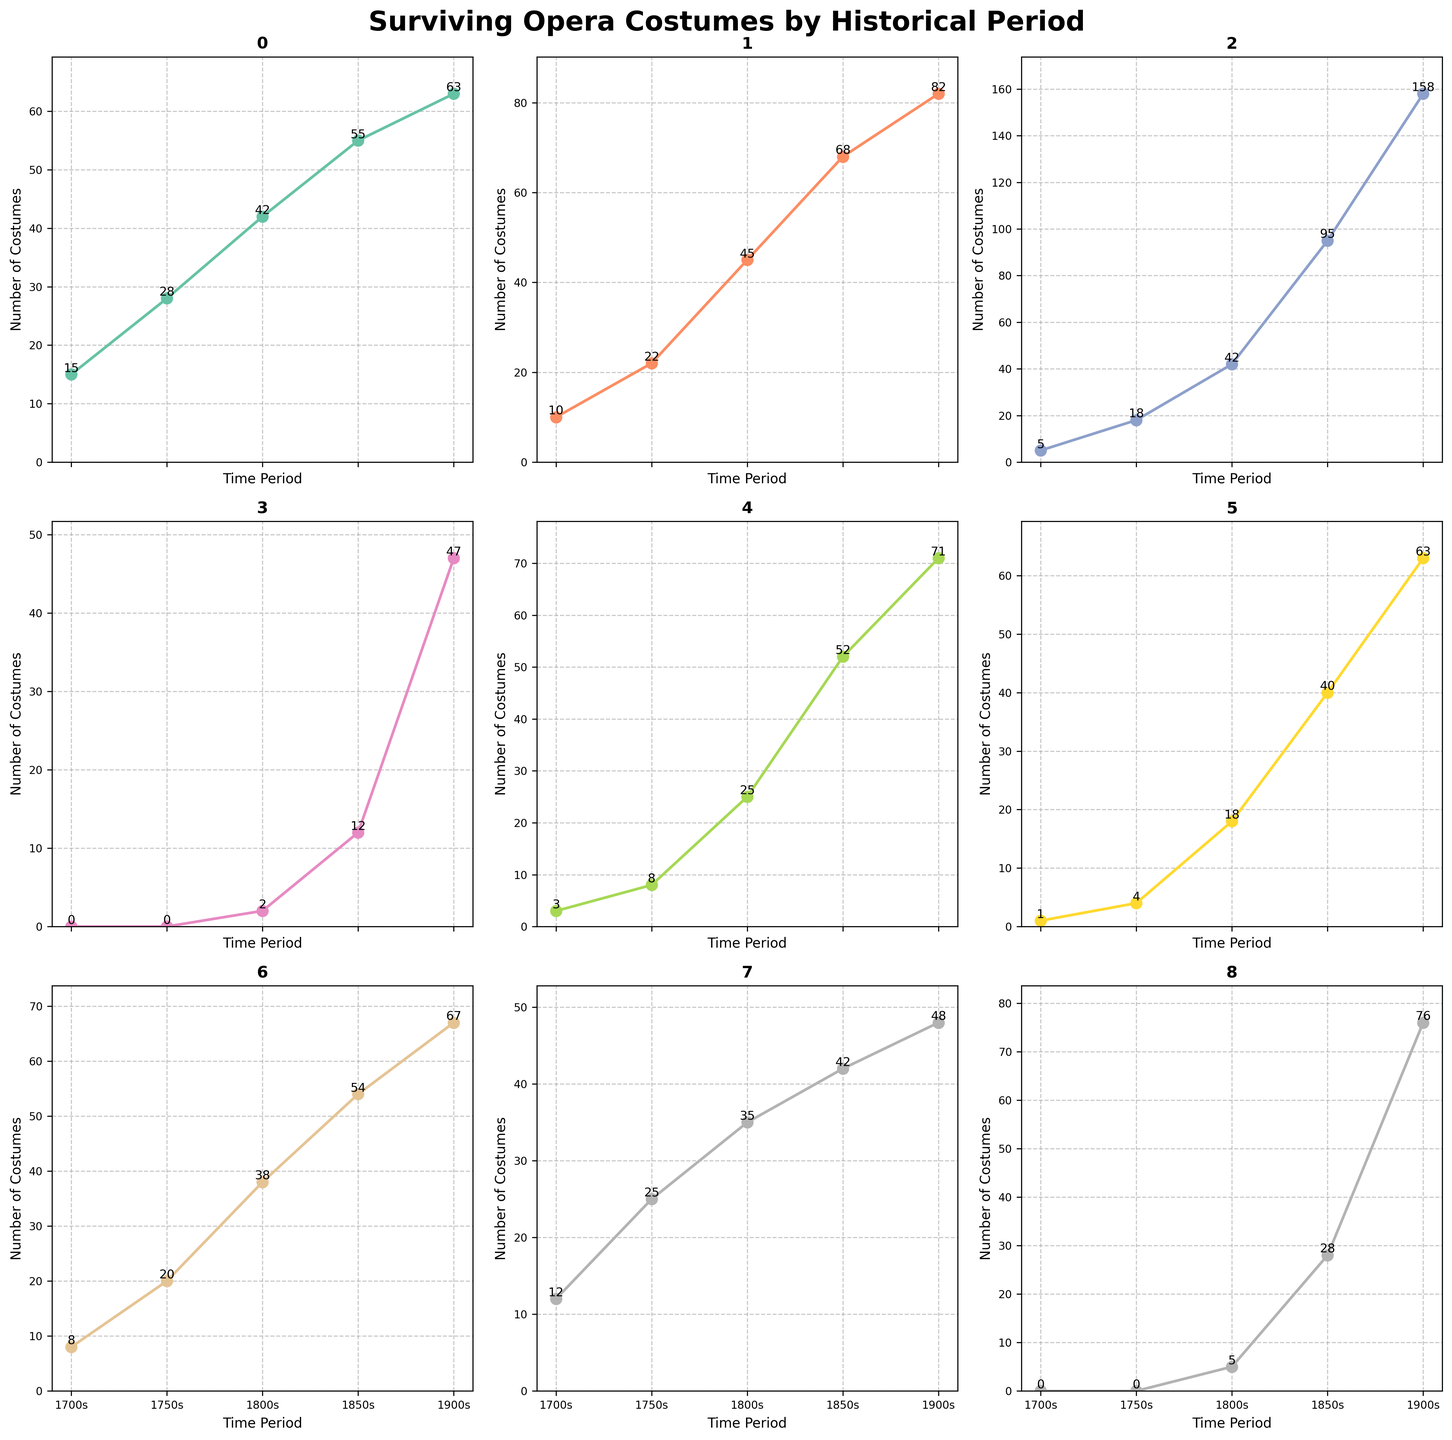How many surviving original opera costumes from the 1900s are recorded for the Romantic period? Looking at the Romantic period subplot, identify the value marked on the line for the 1900s, which is 158.
Answer: 158 Which historical period shows the highest increase in surviving costumes from the 1700s to the 1900s? For each period, calculate the difference between the number of costumes in the 1700s and the 1900s. The Romantic period has the highest increase (158 - 5 = 153).
Answer: Romantic period Compare the number of surviving costumes from the 1850s between the Classical and Grand Opera periods. Which period has more costumes? On the Classical subplot for the 1850s, the value is 68. On the Grand Opera subplot for the same period, the value is 40. Therefore, the Classical period has more costumes.
Answer: Classical period What is the total number of surviving costumes for the Baroque period across all time periods? Add the number of costumes for the Baroque period in each time period: 15 + 28 + 42 + 55 + 63 = 203.
Answer: 203 In the Bel Canto period, how many more costumes are there in the 1850s compared to the 1750s? Subtract the number of costumes in the 1750s (8) from the number of costumes in the 1850s (52). The result is 52 - 8 = 44.
Answer: 44 What is the average number of costumes for Opera Buffa across the 1700s, 1750s, and 1800s? Calculate the average by summing the values for these periods and dividing by 3: (8 + 20 + 38)/3 = 66/3 = 22.
Answer: 22 Which period has the fewest surviving costumes recorded for the 1900s? Compare the values for the 1900s across all periods. The Verismo period has the fewest, with only 47 costumes.
Answer: Verismo period Between the Baroque and Opera Seria periods, which one shows a higher number of surviving costumes in the 1750s? Compare the values for the 1750s: Baroque has 28 costumes, and Opera Seria has 25. Baroque has more.
Answer: Baroque Identify which subplot shows the most rapidly increasing trend in costumes from the 1830s to the 1850s. Look at the slope or sharpness of the increase between 1830s and 1850s in each subplot. The Romantic period subplot shows the steepest increase in this range.
Answer: Romantic period Is the number of surviving costumes from the Operetta period greater in the 1900s than the Grand Opera period in the same time? Compare the value of Operetta in the 1900s (76) to Grand Opera in the 1900s (63). The Operetta period has more.
Answer: Yes 